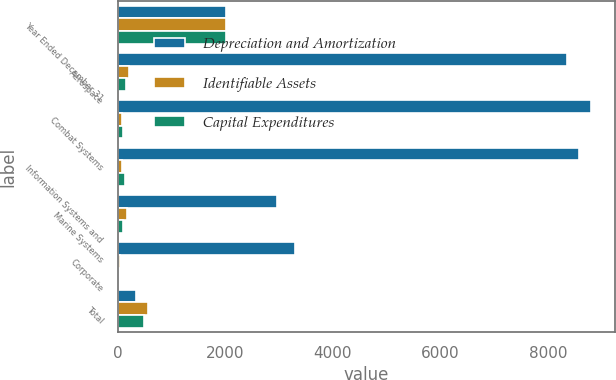<chart> <loc_0><loc_0><loc_500><loc_500><stacked_bar_chart><ecel><fcel>Year Ended December 31<fcel>Aerospace<fcel>Combat Systems<fcel>Information Systems and<fcel>Marine Systems<fcel>Corporate<fcel>Total<nl><fcel>Depreciation and Amortization<fcel>2015<fcel>8358<fcel>8800<fcel>8577<fcel>2970<fcel>3292<fcel>346<nl><fcel>Identifiable Assets<fcel>2015<fcel>210<fcel>79<fcel>73<fcel>166<fcel>41<fcel>569<nl><fcel>Capital Expenditures<fcel>2015<fcel>147<fcel>91<fcel>131<fcel>106<fcel>7<fcel>482<nl></chart> 